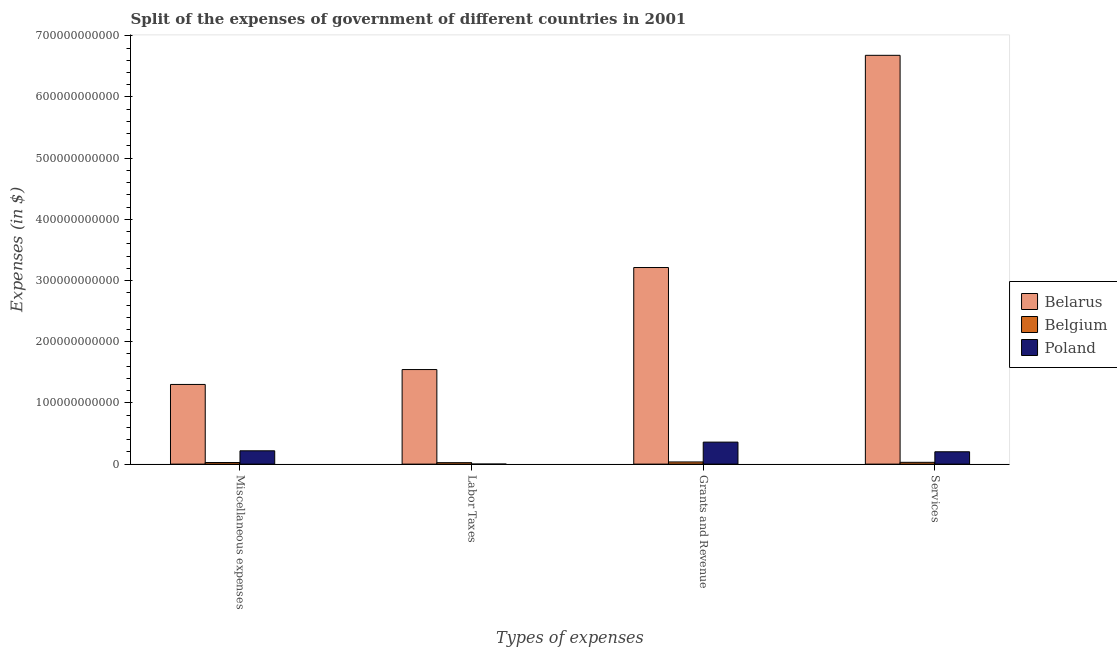Are the number of bars per tick equal to the number of legend labels?
Provide a succinct answer. Yes. Are the number of bars on each tick of the X-axis equal?
Your answer should be compact. Yes. How many bars are there on the 4th tick from the left?
Give a very brief answer. 3. How many bars are there on the 3rd tick from the right?
Your response must be concise. 3. What is the label of the 3rd group of bars from the left?
Make the answer very short. Grants and Revenue. What is the amount spent on services in Belgium?
Your response must be concise. 2.94e+09. Across all countries, what is the maximum amount spent on miscellaneous expenses?
Your response must be concise. 1.30e+11. Across all countries, what is the minimum amount spent on miscellaneous expenses?
Your answer should be compact. 2.59e+09. In which country was the amount spent on labor taxes maximum?
Offer a very short reply. Belarus. What is the total amount spent on miscellaneous expenses in the graph?
Offer a terse response. 1.55e+11. What is the difference between the amount spent on grants and revenue in Poland and that in Belarus?
Provide a short and direct response. -2.85e+11. What is the difference between the amount spent on miscellaneous expenses in Poland and the amount spent on services in Belgium?
Offer a terse response. 1.88e+1. What is the average amount spent on miscellaneous expenses per country?
Keep it short and to the point. 5.15e+1. What is the difference between the amount spent on labor taxes and amount spent on miscellaneous expenses in Belgium?
Give a very brief answer. -2.27e+08. What is the ratio of the amount spent on services in Belarus to that in Poland?
Provide a short and direct response. 33.1. Is the amount spent on grants and revenue in Belarus less than that in Belgium?
Keep it short and to the point. No. Is the difference between the amount spent on services in Belgium and Poland greater than the difference between the amount spent on labor taxes in Belgium and Poland?
Ensure brevity in your answer.  No. What is the difference between the highest and the second highest amount spent on grants and revenue?
Provide a short and direct response. 2.85e+11. What is the difference between the highest and the lowest amount spent on grants and revenue?
Give a very brief answer. 3.18e+11. In how many countries, is the amount spent on miscellaneous expenses greater than the average amount spent on miscellaneous expenses taken over all countries?
Provide a succinct answer. 1. Is the sum of the amount spent on services in Belgium and Belarus greater than the maximum amount spent on grants and revenue across all countries?
Your response must be concise. Yes. What does the 3rd bar from the left in Services represents?
Your response must be concise. Poland. Is it the case that in every country, the sum of the amount spent on miscellaneous expenses and amount spent on labor taxes is greater than the amount spent on grants and revenue?
Give a very brief answer. No. Are all the bars in the graph horizontal?
Give a very brief answer. No. How many countries are there in the graph?
Offer a terse response. 3. What is the difference between two consecutive major ticks on the Y-axis?
Offer a terse response. 1.00e+11. Are the values on the major ticks of Y-axis written in scientific E-notation?
Offer a terse response. No. Does the graph contain any zero values?
Make the answer very short. No. How are the legend labels stacked?
Ensure brevity in your answer.  Vertical. What is the title of the graph?
Your answer should be compact. Split of the expenses of government of different countries in 2001. Does "Brazil" appear as one of the legend labels in the graph?
Your response must be concise. No. What is the label or title of the X-axis?
Your answer should be very brief. Types of expenses. What is the label or title of the Y-axis?
Keep it short and to the point. Expenses (in $). What is the Expenses (in $) in Belarus in Miscellaneous expenses?
Your response must be concise. 1.30e+11. What is the Expenses (in $) in Belgium in Miscellaneous expenses?
Offer a terse response. 2.59e+09. What is the Expenses (in $) of Poland in Miscellaneous expenses?
Offer a terse response. 2.17e+1. What is the Expenses (in $) of Belarus in Labor Taxes?
Your answer should be very brief. 1.55e+11. What is the Expenses (in $) in Belgium in Labor Taxes?
Provide a short and direct response. 2.36e+09. What is the Expenses (in $) of Poland in Labor Taxes?
Offer a terse response. 2.50e+07. What is the Expenses (in $) in Belarus in Grants and Revenue?
Ensure brevity in your answer.  3.21e+11. What is the Expenses (in $) in Belgium in Grants and Revenue?
Offer a very short reply. 3.54e+09. What is the Expenses (in $) in Poland in Grants and Revenue?
Give a very brief answer. 3.60e+1. What is the Expenses (in $) in Belarus in Services?
Your answer should be compact. 6.68e+11. What is the Expenses (in $) in Belgium in Services?
Your answer should be very brief. 2.94e+09. What is the Expenses (in $) of Poland in Services?
Your answer should be very brief. 2.02e+1. Across all Types of expenses, what is the maximum Expenses (in $) of Belarus?
Your response must be concise. 6.68e+11. Across all Types of expenses, what is the maximum Expenses (in $) of Belgium?
Keep it short and to the point. 3.54e+09. Across all Types of expenses, what is the maximum Expenses (in $) in Poland?
Make the answer very short. 3.60e+1. Across all Types of expenses, what is the minimum Expenses (in $) of Belarus?
Offer a very short reply. 1.30e+11. Across all Types of expenses, what is the minimum Expenses (in $) of Belgium?
Your response must be concise. 2.36e+09. Across all Types of expenses, what is the minimum Expenses (in $) in Poland?
Your answer should be compact. 2.50e+07. What is the total Expenses (in $) of Belarus in the graph?
Your response must be concise. 1.27e+12. What is the total Expenses (in $) in Belgium in the graph?
Offer a very short reply. 1.14e+1. What is the total Expenses (in $) in Poland in the graph?
Provide a short and direct response. 7.79e+1. What is the difference between the Expenses (in $) in Belarus in Miscellaneous expenses and that in Labor Taxes?
Make the answer very short. -2.43e+1. What is the difference between the Expenses (in $) in Belgium in Miscellaneous expenses and that in Labor Taxes?
Offer a very short reply. 2.27e+08. What is the difference between the Expenses (in $) in Poland in Miscellaneous expenses and that in Labor Taxes?
Your answer should be very brief. 2.17e+1. What is the difference between the Expenses (in $) in Belarus in Miscellaneous expenses and that in Grants and Revenue?
Keep it short and to the point. -1.91e+11. What is the difference between the Expenses (in $) of Belgium in Miscellaneous expenses and that in Grants and Revenue?
Your response must be concise. -9.47e+08. What is the difference between the Expenses (in $) in Poland in Miscellaneous expenses and that in Grants and Revenue?
Your answer should be compact. -1.42e+1. What is the difference between the Expenses (in $) in Belarus in Miscellaneous expenses and that in Services?
Give a very brief answer. -5.38e+11. What is the difference between the Expenses (in $) in Belgium in Miscellaneous expenses and that in Services?
Ensure brevity in your answer.  -3.48e+08. What is the difference between the Expenses (in $) in Poland in Miscellaneous expenses and that in Services?
Make the answer very short. 1.56e+09. What is the difference between the Expenses (in $) of Belarus in Labor Taxes and that in Grants and Revenue?
Provide a succinct answer. -1.67e+11. What is the difference between the Expenses (in $) of Belgium in Labor Taxes and that in Grants and Revenue?
Make the answer very short. -1.17e+09. What is the difference between the Expenses (in $) in Poland in Labor Taxes and that in Grants and Revenue?
Your answer should be compact. -3.59e+1. What is the difference between the Expenses (in $) in Belarus in Labor Taxes and that in Services?
Offer a terse response. -5.14e+11. What is the difference between the Expenses (in $) in Belgium in Labor Taxes and that in Services?
Ensure brevity in your answer.  -5.75e+08. What is the difference between the Expenses (in $) of Poland in Labor Taxes and that in Services?
Your answer should be very brief. -2.02e+1. What is the difference between the Expenses (in $) of Belarus in Grants and Revenue and that in Services?
Offer a terse response. -3.47e+11. What is the difference between the Expenses (in $) in Belgium in Grants and Revenue and that in Services?
Offer a very short reply. 5.99e+08. What is the difference between the Expenses (in $) of Poland in Grants and Revenue and that in Services?
Your answer should be compact. 1.58e+1. What is the difference between the Expenses (in $) of Belarus in Miscellaneous expenses and the Expenses (in $) of Belgium in Labor Taxes?
Make the answer very short. 1.28e+11. What is the difference between the Expenses (in $) in Belarus in Miscellaneous expenses and the Expenses (in $) in Poland in Labor Taxes?
Your answer should be compact. 1.30e+11. What is the difference between the Expenses (in $) in Belgium in Miscellaneous expenses and the Expenses (in $) in Poland in Labor Taxes?
Your response must be concise. 2.57e+09. What is the difference between the Expenses (in $) of Belarus in Miscellaneous expenses and the Expenses (in $) of Belgium in Grants and Revenue?
Your response must be concise. 1.27e+11. What is the difference between the Expenses (in $) of Belarus in Miscellaneous expenses and the Expenses (in $) of Poland in Grants and Revenue?
Keep it short and to the point. 9.42e+1. What is the difference between the Expenses (in $) in Belgium in Miscellaneous expenses and the Expenses (in $) in Poland in Grants and Revenue?
Keep it short and to the point. -3.34e+1. What is the difference between the Expenses (in $) of Belarus in Miscellaneous expenses and the Expenses (in $) of Belgium in Services?
Ensure brevity in your answer.  1.27e+11. What is the difference between the Expenses (in $) in Belarus in Miscellaneous expenses and the Expenses (in $) in Poland in Services?
Provide a succinct answer. 1.10e+11. What is the difference between the Expenses (in $) of Belgium in Miscellaneous expenses and the Expenses (in $) of Poland in Services?
Make the answer very short. -1.76e+1. What is the difference between the Expenses (in $) in Belarus in Labor Taxes and the Expenses (in $) in Belgium in Grants and Revenue?
Make the answer very short. 1.51e+11. What is the difference between the Expenses (in $) of Belarus in Labor Taxes and the Expenses (in $) of Poland in Grants and Revenue?
Your response must be concise. 1.19e+11. What is the difference between the Expenses (in $) in Belgium in Labor Taxes and the Expenses (in $) in Poland in Grants and Revenue?
Provide a succinct answer. -3.36e+1. What is the difference between the Expenses (in $) in Belarus in Labor Taxes and the Expenses (in $) in Belgium in Services?
Keep it short and to the point. 1.52e+11. What is the difference between the Expenses (in $) of Belarus in Labor Taxes and the Expenses (in $) of Poland in Services?
Give a very brief answer. 1.34e+11. What is the difference between the Expenses (in $) of Belgium in Labor Taxes and the Expenses (in $) of Poland in Services?
Offer a terse response. -1.78e+1. What is the difference between the Expenses (in $) of Belarus in Grants and Revenue and the Expenses (in $) of Belgium in Services?
Your answer should be very brief. 3.18e+11. What is the difference between the Expenses (in $) of Belarus in Grants and Revenue and the Expenses (in $) of Poland in Services?
Keep it short and to the point. 3.01e+11. What is the difference between the Expenses (in $) of Belgium in Grants and Revenue and the Expenses (in $) of Poland in Services?
Keep it short and to the point. -1.66e+1. What is the average Expenses (in $) of Belarus per Types of expenses?
Provide a short and direct response. 3.19e+11. What is the average Expenses (in $) in Belgium per Types of expenses?
Keep it short and to the point. 2.86e+09. What is the average Expenses (in $) in Poland per Types of expenses?
Give a very brief answer. 1.95e+1. What is the difference between the Expenses (in $) of Belarus and Expenses (in $) of Belgium in Miscellaneous expenses?
Keep it short and to the point. 1.28e+11. What is the difference between the Expenses (in $) in Belarus and Expenses (in $) in Poland in Miscellaneous expenses?
Keep it short and to the point. 1.08e+11. What is the difference between the Expenses (in $) in Belgium and Expenses (in $) in Poland in Miscellaneous expenses?
Keep it short and to the point. -1.92e+1. What is the difference between the Expenses (in $) of Belarus and Expenses (in $) of Belgium in Labor Taxes?
Offer a very short reply. 1.52e+11. What is the difference between the Expenses (in $) in Belarus and Expenses (in $) in Poland in Labor Taxes?
Your answer should be very brief. 1.55e+11. What is the difference between the Expenses (in $) of Belgium and Expenses (in $) of Poland in Labor Taxes?
Ensure brevity in your answer.  2.34e+09. What is the difference between the Expenses (in $) in Belarus and Expenses (in $) in Belgium in Grants and Revenue?
Ensure brevity in your answer.  3.18e+11. What is the difference between the Expenses (in $) of Belarus and Expenses (in $) of Poland in Grants and Revenue?
Keep it short and to the point. 2.85e+11. What is the difference between the Expenses (in $) of Belgium and Expenses (in $) of Poland in Grants and Revenue?
Make the answer very short. -3.24e+1. What is the difference between the Expenses (in $) in Belarus and Expenses (in $) in Belgium in Services?
Ensure brevity in your answer.  6.65e+11. What is the difference between the Expenses (in $) in Belarus and Expenses (in $) in Poland in Services?
Make the answer very short. 6.48e+11. What is the difference between the Expenses (in $) of Belgium and Expenses (in $) of Poland in Services?
Ensure brevity in your answer.  -1.72e+1. What is the ratio of the Expenses (in $) in Belarus in Miscellaneous expenses to that in Labor Taxes?
Offer a terse response. 0.84. What is the ratio of the Expenses (in $) in Belgium in Miscellaneous expenses to that in Labor Taxes?
Offer a terse response. 1.1. What is the ratio of the Expenses (in $) in Poland in Miscellaneous expenses to that in Labor Taxes?
Make the answer very short. 869.84. What is the ratio of the Expenses (in $) in Belarus in Miscellaneous expenses to that in Grants and Revenue?
Give a very brief answer. 0.41. What is the ratio of the Expenses (in $) in Belgium in Miscellaneous expenses to that in Grants and Revenue?
Provide a succinct answer. 0.73. What is the ratio of the Expenses (in $) of Poland in Miscellaneous expenses to that in Grants and Revenue?
Your response must be concise. 0.6. What is the ratio of the Expenses (in $) of Belarus in Miscellaneous expenses to that in Services?
Provide a succinct answer. 0.19. What is the ratio of the Expenses (in $) of Belgium in Miscellaneous expenses to that in Services?
Your response must be concise. 0.88. What is the ratio of the Expenses (in $) of Poland in Miscellaneous expenses to that in Services?
Your answer should be compact. 1.08. What is the ratio of the Expenses (in $) of Belarus in Labor Taxes to that in Grants and Revenue?
Your response must be concise. 0.48. What is the ratio of the Expenses (in $) of Belgium in Labor Taxes to that in Grants and Revenue?
Ensure brevity in your answer.  0.67. What is the ratio of the Expenses (in $) in Poland in Labor Taxes to that in Grants and Revenue?
Make the answer very short. 0. What is the ratio of the Expenses (in $) of Belarus in Labor Taxes to that in Services?
Your response must be concise. 0.23. What is the ratio of the Expenses (in $) of Belgium in Labor Taxes to that in Services?
Your answer should be compact. 0.8. What is the ratio of the Expenses (in $) in Poland in Labor Taxes to that in Services?
Make the answer very short. 0. What is the ratio of the Expenses (in $) in Belarus in Grants and Revenue to that in Services?
Keep it short and to the point. 0.48. What is the ratio of the Expenses (in $) in Belgium in Grants and Revenue to that in Services?
Your response must be concise. 1.2. What is the ratio of the Expenses (in $) of Poland in Grants and Revenue to that in Services?
Ensure brevity in your answer.  1.78. What is the difference between the highest and the second highest Expenses (in $) of Belarus?
Provide a succinct answer. 3.47e+11. What is the difference between the highest and the second highest Expenses (in $) in Belgium?
Give a very brief answer. 5.99e+08. What is the difference between the highest and the second highest Expenses (in $) in Poland?
Offer a terse response. 1.42e+1. What is the difference between the highest and the lowest Expenses (in $) in Belarus?
Offer a very short reply. 5.38e+11. What is the difference between the highest and the lowest Expenses (in $) in Belgium?
Make the answer very short. 1.17e+09. What is the difference between the highest and the lowest Expenses (in $) in Poland?
Your response must be concise. 3.59e+1. 